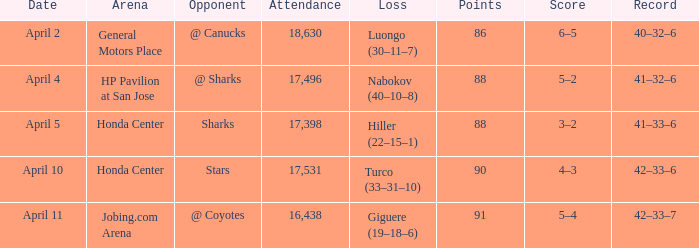Which Loss has a Record of 41–32–6? Nabokov (40–10–8). 